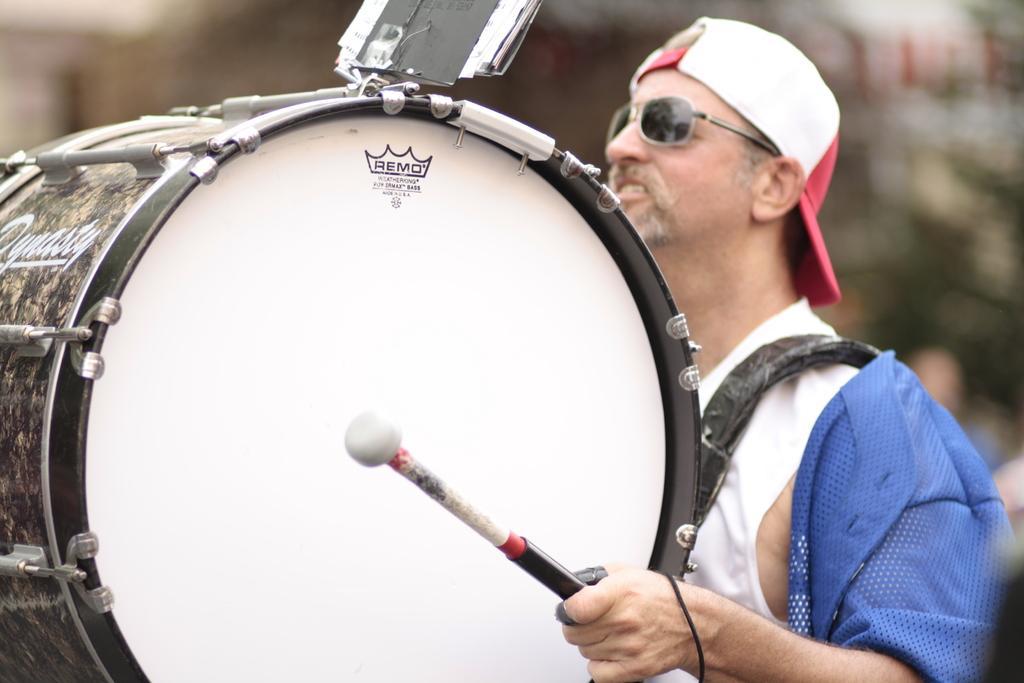Could you give a brief overview of what you see in this image? In this image we can see playing drum. He is wearing white dress with blue coat and cap. 